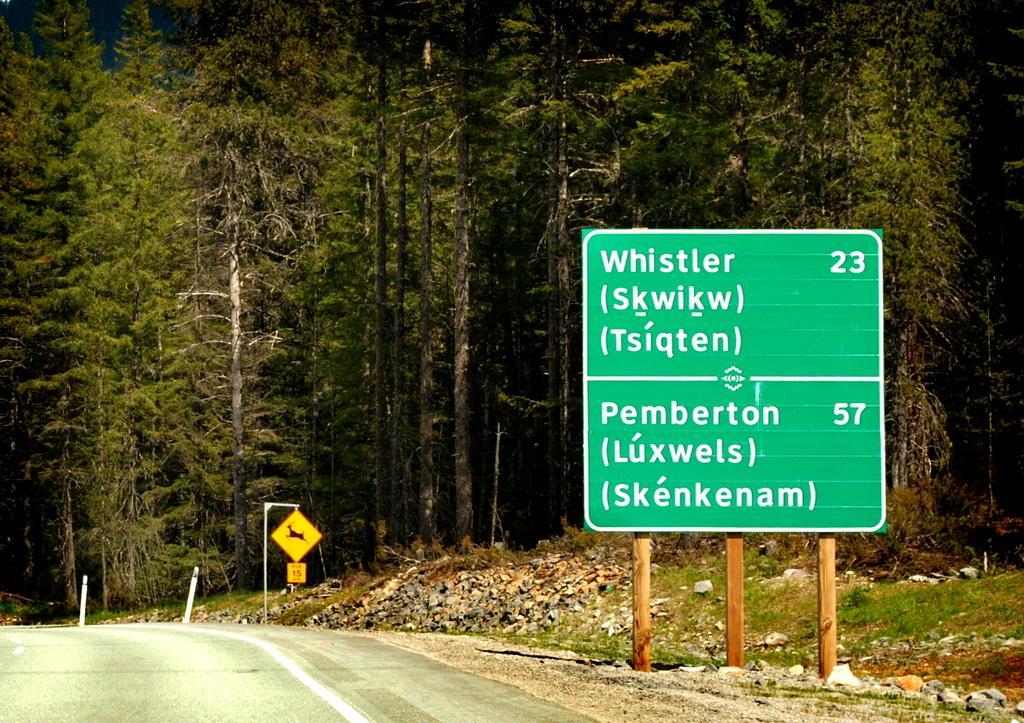Describe this image in one or two sentences. In this picture we can see there are poles with directional boards and sign boards. Behind the boards, there are trees and stones. On the left side of the boards, there is a road. 